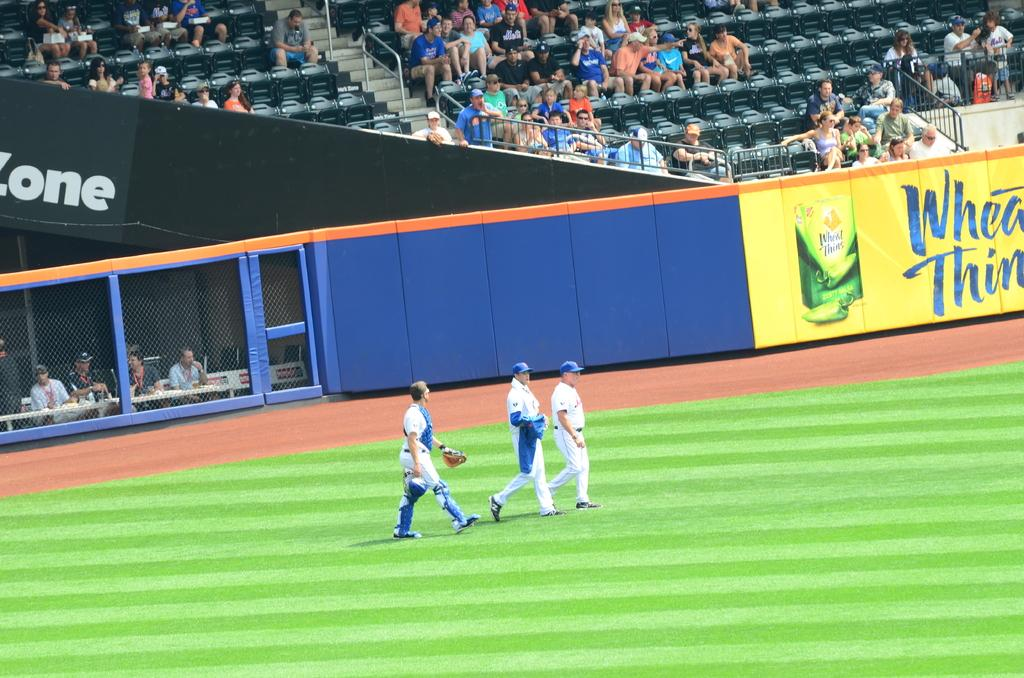<image>
Describe the image concisely. A large Wheat Thins ad plasters the wall of this stadium. 